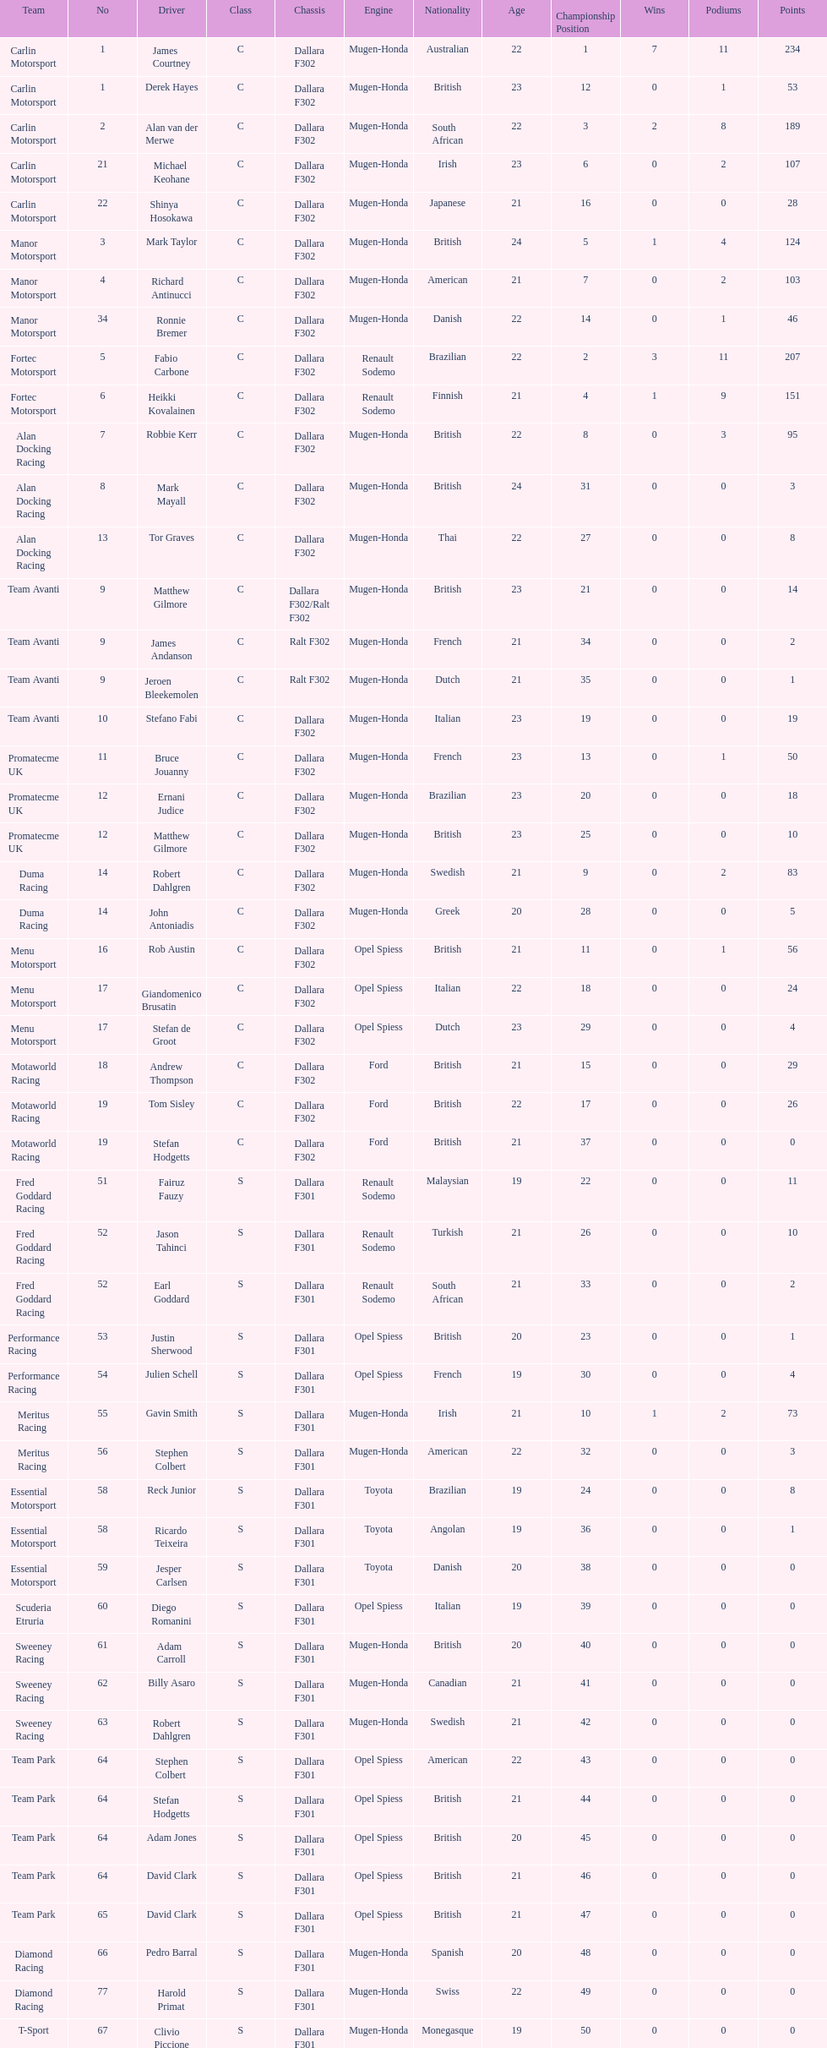I'm looking to parse the entire table for insights. Could you assist me with that? {'header': ['Team', 'No', 'Driver', 'Class', 'Chassis', 'Engine', 'Nationality', 'Age', 'Championship Position', 'Wins', 'Podiums', 'Points'], 'rows': [['Carlin Motorsport', '1', 'James Courtney', 'C', 'Dallara F302', 'Mugen-Honda', 'Australian', '22', '1', '7', '11', '234'], ['Carlin Motorsport', '1', 'Derek Hayes', 'C', 'Dallara F302', 'Mugen-Honda', 'British', '23', '12', '0', '1', '53'], ['Carlin Motorsport', '2', 'Alan van der Merwe', 'C', 'Dallara F302', 'Mugen-Honda', 'South African', '22', '3', '2', '8', '189'], ['Carlin Motorsport', '21', 'Michael Keohane', 'C', 'Dallara F302', 'Mugen-Honda', 'Irish', '23', '6', '0', '2', '107'], ['Carlin Motorsport', '22', 'Shinya Hosokawa', 'C', 'Dallara F302', 'Mugen-Honda', 'Japanese', '21', '16', '0', '0', '28'], ['Manor Motorsport', '3', 'Mark Taylor', 'C', 'Dallara F302', 'Mugen-Honda', 'British', '24', '5', '1', '4', '124'], ['Manor Motorsport', '4', 'Richard Antinucci', 'C', 'Dallara F302', 'Mugen-Honda', 'American', '21', '7', '0', '2', '103'], ['Manor Motorsport', '34', 'Ronnie Bremer', 'C', 'Dallara F302', 'Mugen-Honda', 'Danish', '22', '14', '0', '1', '46'], ['Fortec Motorsport', '5', 'Fabio Carbone', 'C', 'Dallara F302', 'Renault Sodemo', 'Brazilian', '22', '2', '3', '11', '207'], ['Fortec Motorsport', '6', 'Heikki Kovalainen', 'C', 'Dallara F302', 'Renault Sodemo', 'Finnish', '21', '4', '1', '9', '151'], ['Alan Docking Racing', '7', 'Robbie Kerr', 'C', 'Dallara F302', 'Mugen-Honda', 'British', '22', '8', '0', '3', '95'], ['Alan Docking Racing', '8', 'Mark Mayall', 'C', 'Dallara F302', 'Mugen-Honda', 'British', '24', '31', '0', '0', '3'], ['Alan Docking Racing', '13', 'Tor Graves', 'C', 'Dallara F302', 'Mugen-Honda', 'Thai', '22', '27', '0', '0', '8'], ['Team Avanti', '9', 'Matthew Gilmore', 'C', 'Dallara F302/Ralt F302', 'Mugen-Honda', 'British', '23', '21', '0', '0', '14'], ['Team Avanti', '9', 'James Andanson', 'C', 'Ralt F302', 'Mugen-Honda', 'French', '21', '34', '0', '0', '2'], ['Team Avanti', '9', 'Jeroen Bleekemolen', 'C', 'Ralt F302', 'Mugen-Honda', 'Dutch', '21', '35', '0', '0', '1'], ['Team Avanti', '10', 'Stefano Fabi', 'C', 'Dallara F302', 'Mugen-Honda', 'Italian', '23', '19', '0', '0', '19'], ['Promatecme UK', '11', 'Bruce Jouanny', 'C', 'Dallara F302', 'Mugen-Honda', 'French', '23', '13', '0', '1', '50'], ['Promatecme UK', '12', 'Ernani Judice', 'C', 'Dallara F302', 'Mugen-Honda', 'Brazilian', '23', '20', '0', '0', '18'], ['Promatecme UK', '12', 'Matthew Gilmore', 'C', 'Dallara F302', 'Mugen-Honda', 'British', '23', '25', '0', '0', '10'], ['Duma Racing', '14', 'Robert Dahlgren', 'C', 'Dallara F302', 'Mugen-Honda', 'Swedish', '21', '9', '0', '2', '83'], ['Duma Racing', '14', 'John Antoniadis', 'C', 'Dallara F302', 'Mugen-Honda', 'Greek', '20', '28', '0', '0', '5'], ['Menu Motorsport', '16', 'Rob Austin', 'C', 'Dallara F302', 'Opel Spiess', 'British', '21', '11', '0', '1', '56'], ['Menu Motorsport', '17', 'Giandomenico Brusatin', 'C', 'Dallara F302', 'Opel Spiess', 'Italian', '22', '18', '0', '0', '24'], ['Menu Motorsport', '17', 'Stefan de Groot', 'C', 'Dallara F302', 'Opel Spiess', 'Dutch', '23', '29', '0', '0', '4'], ['Motaworld Racing', '18', 'Andrew Thompson', 'C', 'Dallara F302', 'Ford', 'British', '21', '15', '0', '0', '29'], ['Motaworld Racing', '19', 'Tom Sisley', 'C', 'Dallara F302', 'Ford', 'British', '22', '17', '0', '0', '26'], ['Motaworld Racing', '19', 'Stefan Hodgetts', 'C', 'Dallara F302', 'Ford', 'British', '21', '37', '0', '0', '0'], ['Fred Goddard Racing', '51', 'Fairuz Fauzy', 'S', 'Dallara F301', 'Renault Sodemo', 'Malaysian', '19', '22', '0', '0', '11'], ['Fred Goddard Racing', '52', 'Jason Tahinci', 'S', 'Dallara F301', 'Renault Sodemo', 'Turkish', '21', '26', '0', '0', '10'], ['Fred Goddard Racing', '52', 'Earl Goddard', 'S', 'Dallara F301', 'Renault Sodemo', 'South African', '21', '33', '0', '0', '2'], ['Performance Racing', '53', 'Justin Sherwood', 'S', 'Dallara F301', 'Opel Spiess', 'British', '20', '23', '0', '0', '1'], ['Performance Racing', '54', 'Julien Schell', 'S', 'Dallara F301', 'Opel Spiess', 'French', '19', '30', '0', '0', '4'], ['Meritus Racing', '55', 'Gavin Smith', 'S', 'Dallara F301', 'Mugen-Honda', 'Irish', '21', '10', '1', '2', '73'], ['Meritus Racing', '56', 'Stephen Colbert', 'S', 'Dallara F301', 'Mugen-Honda', 'American', '22', '32', '0', '0', '3'], ['Essential Motorsport', '58', 'Reck Junior', 'S', 'Dallara F301', 'Toyota', 'Brazilian', '19', '24', '0', '0', '8'], ['Essential Motorsport', '58', 'Ricardo Teixeira', 'S', 'Dallara F301', 'Toyota', 'Angolan', '19', '36', '0', '0', '1'], ['Essential Motorsport', '59', 'Jesper Carlsen', 'S', 'Dallara F301', 'Toyota', 'Danish', '20', '38', '0', '0', '0'], ['Scuderia Etruria', '60', 'Diego Romanini', 'S', 'Dallara F301', 'Opel Spiess', 'Italian', '19', '39', '0', '0', '0'], ['Sweeney Racing', '61', 'Adam Carroll', 'S', 'Dallara F301', 'Mugen-Honda', 'British', '20', '40', '0', '0', '0'], ['Sweeney Racing', '62', 'Billy Asaro', 'S', 'Dallara F301', 'Mugen-Honda', 'Canadian', '21', '41', '0', '0', '0'], ['Sweeney Racing', '63', 'Robert Dahlgren', 'S', 'Dallara F301', 'Mugen-Honda', 'Swedish', '21', '42', '0', '0', '0'], ['Team Park', '64', 'Stephen Colbert', 'S', 'Dallara F301', 'Opel Spiess', 'American', '22', '43', '0', '0', '0'], ['Team Park', '64', 'Stefan Hodgetts', 'S', 'Dallara F301', 'Opel Spiess', 'British', '21', '44', '0', '0', '0'], ['Team Park', '64', 'Adam Jones', 'S', 'Dallara F301', 'Opel Spiess', 'British', '20', '45', '0', '0', '0'], ['Team Park', '64', 'David Clark', 'S', 'Dallara F301', 'Opel Spiess', 'British', '21', '46', '0', '0', '0'], ['Team Park', '65', 'David Clark', 'S', 'Dallara F301', 'Opel Spiess', 'British', '21', '47', '0', '0', '0'], ['Diamond Racing', '66', 'Pedro Barral', 'S', 'Dallara F301', 'Mugen-Honda', 'Spanish', '20', '48', '0', '0', '0'], ['Diamond Racing', '77', 'Harold Primat', 'S', 'Dallara F301', 'Mugen-Honda', 'Swiss', '22', '49', '0', '0', '0'], ['T-Sport', '67', 'Clivio Piccione', 'S', 'Dallara F301', 'Mugen-Honda', 'Monegasque', '19', '50', '0', '0', '0'], ['T-Sport', '68', 'Karun Chandhok', 'S', 'Dallara F301', 'Mugen-Honda', 'Indian', '18', '51', '0', '0', '0'], ['Hill Speed Motorsport', '69', 'Luke Stevens', 'S', 'Dallara F301', 'Opel Spiess', 'British', '21', '52', '0', '0', '0']]} Which engine was used the most by teams this season? Mugen-Honda. 